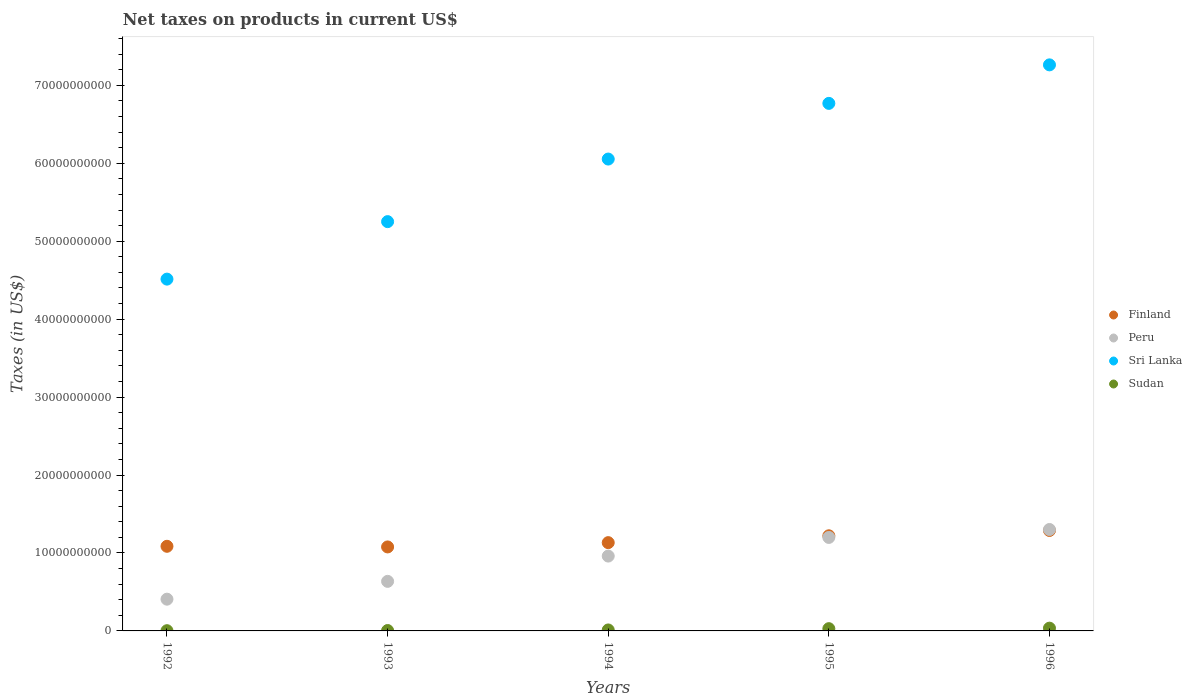What is the net taxes on products in Sudan in 1992?
Ensure brevity in your answer.  2.94e+07. Across all years, what is the maximum net taxes on products in Sudan?
Provide a short and direct response. 3.55e+08. Across all years, what is the minimum net taxes on products in Sudan?
Your response must be concise. 2.94e+07. In which year was the net taxes on products in Finland maximum?
Provide a short and direct response. 1996. In which year was the net taxes on products in Sudan minimum?
Keep it short and to the point. 1992. What is the total net taxes on products in Sri Lanka in the graph?
Keep it short and to the point. 2.98e+11. What is the difference between the net taxes on products in Sudan in 1994 and that in 1996?
Provide a short and direct response. -2.30e+08. What is the difference between the net taxes on products in Peru in 1993 and the net taxes on products in Sri Lanka in 1992?
Provide a short and direct response. -3.88e+1. What is the average net taxes on products in Sudan per year?
Keep it short and to the point. 1.70e+08. In the year 1996, what is the difference between the net taxes on products in Sri Lanka and net taxes on products in Finland?
Offer a very short reply. 5.97e+1. In how many years, is the net taxes on products in Sudan greater than 36000000000 US$?
Offer a very short reply. 0. What is the ratio of the net taxes on products in Sudan in 1992 to that in 1995?
Keep it short and to the point. 0.1. Is the difference between the net taxes on products in Sri Lanka in 1993 and 1994 greater than the difference between the net taxes on products in Finland in 1993 and 1994?
Give a very brief answer. No. What is the difference between the highest and the second highest net taxes on products in Sri Lanka?
Offer a very short reply. 4.94e+09. What is the difference between the highest and the lowest net taxes on products in Sudan?
Your answer should be very brief. 3.26e+08. In how many years, is the net taxes on products in Sri Lanka greater than the average net taxes on products in Sri Lanka taken over all years?
Provide a short and direct response. 3. Is the sum of the net taxes on products in Finland in 1994 and 1996 greater than the maximum net taxes on products in Sudan across all years?
Provide a short and direct response. Yes. Is it the case that in every year, the sum of the net taxes on products in Sri Lanka and net taxes on products in Sudan  is greater than the net taxes on products in Peru?
Ensure brevity in your answer.  Yes. Does the net taxes on products in Finland monotonically increase over the years?
Provide a short and direct response. No. Is the net taxes on products in Sri Lanka strictly greater than the net taxes on products in Finland over the years?
Keep it short and to the point. Yes. Is the net taxes on products in Peru strictly less than the net taxes on products in Finland over the years?
Make the answer very short. No. How many dotlines are there?
Ensure brevity in your answer.  4. How many years are there in the graph?
Give a very brief answer. 5. What is the difference between two consecutive major ticks on the Y-axis?
Your response must be concise. 1.00e+1. Does the graph contain grids?
Provide a short and direct response. No. How many legend labels are there?
Keep it short and to the point. 4. What is the title of the graph?
Your answer should be very brief. Net taxes on products in current US$. Does "Sub-Saharan Africa (all income levels)" appear as one of the legend labels in the graph?
Provide a succinct answer. No. What is the label or title of the Y-axis?
Provide a short and direct response. Taxes (in US$). What is the Taxes (in US$) in Finland in 1992?
Ensure brevity in your answer.  1.09e+1. What is the Taxes (in US$) of Peru in 1992?
Your answer should be very brief. 4.07e+09. What is the Taxes (in US$) in Sri Lanka in 1992?
Provide a succinct answer. 4.51e+1. What is the Taxes (in US$) in Sudan in 1992?
Provide a short and direct response. 2.94e+07. What is the Taxes (in US$) in Finland in 1993?
Offer a very short reply. 1.08e+1. What is the Taxes (in US$) in Peru in 1993?
Your answer should be compact. 6.36e+09. What is the Taxes (in US$) in Sri Lanka in 1993?
Provide a succinct answer. 5.25e+1. What is the Taxes (in US$) in Sudan in 1993?
Your answer should be very brief. 5.04e+07. What is the Taxes (in US$) of Finland in 1994?
Offer a terse response. 1.13e+1. What is the Taxes (in US$) of Peru in 1994?
Your answer should be very brief. 9.60e+09. What is the Taxes (in US$) of Sri Lanka in 1994?
Your answer should be compact. 6.05e+1. What is the Taxes (in US$) of Sudan in 1994?
Your answer should be compact. 1.25e+08. What is the Taxes (in US$) in Finland in 1995?
Ensure brevity in your answer.  1.22e+1. What is the Taxes (in US$) of Peru in 1995?
Offer a very short reply. 1.20e+1. What is the Taxes (in US$) of Sri Lanka in 1995?
Keep it short and to the point. 6.77e+1. What is the Taxes (in US$) of Sudan in 1995?
Your response must be concise. 2.90e+08. What is the Taxes (in US$) of Finland in 1996?
Your answer should be very brief. 1.29e+1. What is the Taxes (in US$) in Peru in 1996?
Provide a succinct answer. 1.30e+1. What is the Taxes (in US$) of Sri Lanka in 1996?
Provide a short and direct response. 7.26e+1. What is the Taxes (in US$) of Sudan in 1996?
Your answer should be compact. 3.55e+08. Across all years, what is the maximum Taxes (in US$) of Finland?
Give a very brief answer. 1.29e+1. Across all years, what is the maximum Taxes (in US$) in Peru?
Ensure brevity in your answer.  1.30e+1. Across all years, what is the maximum Taxes (in US$) in Sri Lanka?
Your answer should be very brief. 7.26e+1. Across all years, what is the maximum Taxes (in US$) of Sudan?
Provide a succinct answer. 3.55e+08. Across all years, what is the minimum Taxes (in US$) in Finland?
Provide a short and direct response. 1.08e+1. Across all years, what is the minimum Taxes (in US$) of Peru?
Provide a short and direct response. 4.07e+09. Across all years, what is the minimum Taxes (in US$) in Sri Lanka?
Give a very brief answer. 4.51e+1. Across all years, what is the minimum Taxes (in US$) in Sudan?
Your answer should be very brief. 2.94e+07. What is the total Taxes (in US$) in Finland in the graph?
Give a very brief answer. 5.81e+1. What is the total Taxes (in US$) of Peru in the graph?
Make the answer very short. 4.50e+1. What is the total Taxes (in US$) of Sri Lanka in the graph?
Ensure brevity in your answer.  2.98e+11. What is the total Taxes (in US$) of Sudan in the graph?
Your response must be concise. 8.49e+08. What is the difference between the Taxes (in US$) in Finland in 1992 and that in 1993?
Offer a terse response. 8.20e+07. What is the difference between the Taxes (in US$) of Peru in 1992 and that in 1993?
Make the answer very short. -2.29e+09. What is the difference between the Taxes (in US$) of Sri Lanka in 1992 and that in 1993?
Ensure brevity in your answer.  -7.38e+09. What is the difference between the Taxes (in US$) of Sudan in 1992 and that in 1993?
Offer a very short reply. -2.11e+07. What is the difference between the Taxes (in US$) in Finland in 1992 and that in 1994?
Your answer should be very brief. -4.69e+08. What is the difference between the Taxes (in US$) in Peru in 1992 and that in 1994?
Give a very brief answer. -5.53e+09. What is the difference between the Taxes (in US$) of Sri Lanka in 1992 and that in 1994?
Your answer should be compact. -1.54e+1. What is the difference between the Taxes (in US$) of Sudan in 1992 and that in 1994?
Provide a short and direct response. -9.51e+07. What is the difference between the Taxes (in US$) in Finland in 1992 and that in 1995?
Your response must be concise. -1.35e+09. What is the difference between the Taxes (in US$) in Peru in 1992 and that in 1995?
Provide a short and direct response. -7.92e+09. What is the difference between the Taxes (in US$) in Sri Lanka in 1992 and that in 1995?
Give a very brief answer. -2.25e+1. What is the difference between the Taxes (in US$) in Sudan in 1992 and that in 1995?
Make the answer very short. -2.60e+08. What is the difference between the Taxes (in US$) in Finland in 1992 and that in 1996?
Offer a terse response. -2.03e+09. What is the difference between the Taxes (in US$) in Peru in 1992 and that in 1996?
Offer a terse response. -8.94e+09. What is the difference between the Taxes (in US$) in Sri Lanka in 1992 and that in 1996?
Give a very brief answer. -2.75e+1. What is the difference between the Taxes (in US$) of Sudan in 1992 and that in 1996?
Offer a very short reply. -3.26e+08. What is the difference between the Taxes (in US$) of Finland in 1993 and that in 1994?
Make the answer very short. -5.51e+08. What is the difference between the Taxes (in US$) in Peru in 1993 and that in 1994?
Your response must be concise. -3.25e+09. What is the difference between the Taxes (in US$) in Sri Lanka in 1993 and that in 1994?
Offer a very short reply. -8.03e+09. What is the difference between the Taxes (in US$) in Sudan in 1993 and that in 1994?
Give a very brief answer. -7.41e+07. What is the difference between the Taxes (in US$) of Finland in 1993 and that in 1995?
Ensure brevity in your answer.  -1.43e+09. What is the difference between the Taxes (in US$) in Peru in 1993 and that in 1995?
Ensure brevity in your answer.  -5.64e+09. What is the difference between the Taxes (in US$) of Sri Lanka in 1993 and that in 1995?
Offer a terse response. -1.52e+1. What is the difference between the Taxes (in US$) in Sudan in 1993 and that in 1995?
Give a very brief answer. -2.39e+08. What is the difference between the Taxes (in US$) in Finland in 1993 and that in 1996?
Provide a short and direct response. -2.11e+09. What is the difference between the Taxes (in US$) in Peru in 1993 and that in 1996?
Offer a terse response. -6.65e+09. What is the difference between the Taxes (in US$) in Sri Lanka in 1993 and that in 1996?
Ensure brevity in your answer.  -2.01e+1. What is the difference between the Taxes (in US$) in Sudan in 1993 and that in 1996?
Your response must be concise. -3.05e+08. What is the difference between the Taxes (in US$) of Finland in 1994 and that in 1995?
Ensure brevity in your answer.  -8.78e+08. What is the difference between the Taxes (in US$) in Peru in 1994 and that in 1995?
Keep it short and to the point. -2.39e+09. What is the difference between the Taxes (in US$) of Sri Lanka in 1994 and that in 1995?
Your response must be concise. -7.14e+09. What is the difference between the Taxes (in US$) in Sudan in 1994 and that in 1995?
Offer a terse response. -1.65e+08. What is the difference between the Taxes (in US$) in Finland in 1994 and that in 1996?
Ensure brevity in your answer.  -1.56e+09. What is the difference between the Taxes (in US$) in Peru in 1994 and that in 1996?
Offer a terse response. -3.41e+09. What is the difference between the Taxes (in US$) of Sri Lanka in 1994 and that in 1996?
Give a very brief answer. -1.21e+1. What is the difference between the Taxes (in US$) of Sudan in 1994 and that in 1996?
Provide a succinct answer. -2.30e+08. What is the difference between the Taxes (in US$) of Finland in 1995 and that in 1996?
Provide a short and direct response. -6.85e+08. What is the difference between the Taxes (in US$) of Peru in 1995 and that in 1996?
Ensure brevity in your answer.  -1.02e+09. What is the difference between the Taxes (in US$) in Sri Lanka in 1995 and that in 1996?
Keep it short and to the point. -4.94e+09. What is the difference between the Taxes (in US$) in Sudan in 1995 and that in 1996?
Your answer should be compact. -6.54e+07. What is the difference between the Taxes (in US$) in Finland in 1992 and the Taxes (in US$) in Peru in 1993?
Ensure brevity in your answer.  4.50e+09. What is the difference between the Taxes (in US$) in Finland in 1992 and the Taxes (in US$) in Sri Lanka in 1993?
Your answer should be compact. -4.17e+1. What is the difference between the Taxes (in US$) in Finland in 1992 and the Taxes (in US$) in Sudan in 1993?
Keep it short and to the point. 1.08e+1. What is the difference between the Taxes (in US$) in Peru in 1992 and the Taxes (in US$) in Sri Lanka in 1993?
Your answer should be compact. -4.84e+1. What is the difference between the Taxes (in US$) of Peru in 1992 and the Taxes (in US$) of Sudan in 1993?
Ensure brevity in your answer.  4.02e+09. What is the difference between the Taxes (in US$) in Sri Lanka in 1992 and the Taxes (in US$) in Sudan in 1993?
Offer a very short reply. 4.51e+1. What is the difference between the Taxes (in US$) of Finland in 1992 and the Taxes (in US$) of Peru in 1994?
Offer a very short reply. 1.25e+09. What is the difference between the Taxes (in US$) in Finland in 1992 and the Taxes (in US$) in Sri Lanka in 1994?
Keep it short and to the point. -4.97e+1. What is the difference between the Taxes (in US$) in Finland in 1992 and the Taxes (in US$) in Sudan in 1994?
Offer a terse response. 1.07e+1. What is the difference between the Taxes (in US$) in Peru in 1992 and the Taxes (in US$) in Sri Lanka in 1994?
Ensure brevity in your answer.  -5.65e+1. What is the difference between the Taxes (in US$) of Peru in 1992 and the Taxes (in US$) of Sudan in 1994?
Give a very brief answer. 3.95e+09. What is the difference between the Taxes (in US$) in Sri Lanka in 1992 and the Taxes (in US$) in Sudan in 1994?
Give a very brief answer. 4.50e+1. What is the difference between the Taxes (in US$) in Finland in 1992 and the Taxes (in US$) in Peru in 1995?
Ensure brevity in your answer.  -1.14e+09. What is the difference between the Taxes (in US$) of Finland in 1992 and the Taxes (in US$) of Sri Lanka in 1995?
Your answer should be very brief. -5.68e+1. What is the difference between the Taxes (in US$) in Finland in 1992 and the Taxes (in US$) in Sudan in 1995?
Your answer should be compact. 1.06e+1. What is the difference between the Taxes (in US$) of Peru in 1992 and the Taxes (in US$) of Sri Lanka in 1995?
Offer a very short reply. -6.36e+1. What is the difference between the Taxes (in US$) in Peru in 1992 and the Taxes (in US$) in Sudan in 1995?
Ensure brevity in your answer.  3.78e+09. What is the difference between the Taxes (in US$) in Sri Lanka in 1992 and the Taxes (in US$) in Sudan in 1995?
Offer a very short reply. 4.48e+1. What is the difference between the Taxes (in US$) of Finland in 1992 and the Taxes (in US$) of Peru in 1996?
Your response must be concise. -2.16e+09. What is the difference between the Taxes (in US$) of Finland in 1992 and the Taxes (in US$) of Sri Lanka in 1996?
Ensure brevity in your answer.  -6.18e+1. What is the difference between the Taxes (in US$) in Finland in 1992 and the Taxes (in US$) in Sudan in 1996?
Ensure brevity in your answer.  1.05e+1. What is the difference between the Taxes (in US$) of Peru in 1992 and the Taxes (in US$) of Sri Lanka in 1996?
Offer a terse response. -6.85e+1. What is the difference between the Taxes (in US$) in Peru in 1992 and the Taxes (in US$) in Sudan in 1996?
Keep it short and to the point. 3.72e+09. What is the difference between the Taxes (in US$) of Sri Lanka in 1992 and the Taxes (in US$) of Sudan in 1996?
Keep it short and to the point. 4.48e+1. What is the difference between the Taxes (in US$) in Finland in 1993 and the Taxes (in US$) in Peru in 1994?
Provide a short and direct response. 1.17e+09. What is the difference between the Taxes (in US$) in Finland in 1993 and the Taxes (in US$) in Sri Lanka in 1994?
Give a very brief answer. -4.98e+1. What is the difference between the Taxes (in US$) in Finland in 1993 and the Taxes (in US$) in Sudan in 1994?
Keep it short and to the point. 1.07e+1. What is the difference between the Taxes (in US$) in Peru in 1993 and the Taxes (in US$) in Sri Lanka in 1994?
Ensure brevity in your answer.  -5.42e+1. What is the difference between the Taxes (in US$) in Peru in 1993 and the Taxes (in US$) in Sudan in 1994?
Keep it short and to the point. 6.23e+09. What is the difference between the Taxes (in US$) of Sri Lanka in 1993 and the Taxes (in US$) of Sudan in 1994?
Keep it short and to the point. 5.24e+1. What is the difference between the Taxes (in US$) in Finland in 1993 and the Taxes (in US$) in Peru in 1995?
Offer a very short reply. -1.22e+09. What is the difference between the Taxes (in US$) of Finland in 1993 and the Taxes (in US$) of Sri Lanka in 1995?
Ensure brevity in your answer.  -5.69e+1. What is the difference between the Taxes (in US$) of Finland in 1993 and the Taxes (in US$) of Sudan in 1995?
Give a very brief answer. 1.05e+1. What is the difference between the Taxes (in US$) in Peru in 1993 and the Taxes (in US$) in Sri Lanka in 1995?
Your answer should be very brief. -6.13e+1. What is the difference between the Taxes (in US$) of Peru in 1993 and the Taxes (in US$) of Sudan in 1995?
Give a very brief answer. 6.07e+09. What is the difference between the Taxes (in US$) of Sri Lanka in 1993 and the Taxes (in US$) of Sudan in 1995?
Keep it short and to the point. 5.22e+1. What is the difference between the Taxes (in US$) in Finland in 1993 and the Taxes (in US$) in Peru in 1996?
Make the answer very short. -2.24e+09. What is the difference between the Taxes (in US$) of Finland in 1993 and the Taxes (in US$) of Sri Lanka in 1996?
Ensure brevity in your answer.  -6.18e+1. What is the difference between the Taxes (in US$) of Finland in 1993 and the Taxes (in US$) of Sudan in 1996?
Ensure brevity in your answer.  1.04e+1. What is the difference between the Taxes (in US$) of Peru in 1993 and the Taxes (in US$) of Sri Lanka in 1996?
Offer a very short reply. -6.63e+1. What is the difference between the Taxes (in US$) in Peru in 1993 and the Taxes (in US$) in Sudan in 1996?
Your answer should be compact. 6.00e+09. What is the difference between the Taxes (in US$) in Sri Lanka in 1993 and the Taxes (in US$) in Sudan in 1996?
Your answer should be compact. 5.22e+1. What is the difference between the Taxes (in US$) in Finland in 1994 and the Taxes (in US$) in Peru in 1995?
Your answer should be compact. -6.68e+08. What is the difference between the Taxes (in US$) of Finland in 1994 and the Taxes (in US$) of Sri Lanka in 1995?
Provide a succinct answer. -5.64e+1. What is the difference between the Taxes (in US$) in Finland in 1994 and the Taxes (in US$) in Sudan in 1995?
Offer a very short reply. 1.10e+1. What is the difference between the Taxes (in US$) of Peru in 1994 and the Taxes (in US$) of Sri Lanka in 1995?
Provide a succinct answer. -5.81e+1. What is the difference between the Taxes (in US$) in Peru in 1994 and the Taxes (in US$) in Sudan in 1995?
Your response must be concise. 9.31e+09. What is the difference between the Taxes (in US$) of Sri Lanka in 1994 and the Taxes (in US$) of Sudan in 1995?
Give a very brief answer. 6.02e+1. What is the difference between the Taxes (in US$) in Finland in 1994 and the Taxes (in US$) in Peru in 1996?
Your response must be concise. -1.69e+09. What is the difference between the Taxes (in US$) of Finland in 1994 and the Taxes (in US$) of Sri Lanka in 1996?
Give a very brief answer. -6.13e+1. What is the difference between the Taxes (in US$) in Finland in 1994 and the Taxes (in US$) in Sudan in 1996?
Your response must be concise. 1.10e+1. What is the difference between the Taxes (in US$) in Peru in 1994 and the Taxes (in US$) in Sri Lanka in 1996?
Keep it short and to the point. -6.30e+1. What is the difference between the Taxes (in US$) in Peru in 1994 and the Taxes (in US$) in Sudan in 1996?
Provide a succinct answer. 9.25e+09. What is the difference between the Taxes (in US$) in Sri Lanka in 1994 and the Taxes (in US$) in Sudan in 1996?
Give a very brief answer. 6.02e+1. What is the difference between the Taxes (in US$) in Finland in 1995 and the Taxes (in US$) in Peru in 1996?
Make the answer very short. -8.09e+08. What is the difference between the Taxes (in US$) in Finland in 1995 and the Taxes (in US$) in Sri Lanka in 1996?
Offer a very short reply. -6.04e+1. What is the difference between the Taxes (in US$) in Finland in 1995 and the Taxes (in US$) in Sudan in 1996?
Make the answer very short. 1.18e+1. What is the difference between the Taxes (in US$) in Peru in 1995 and the Taxes (in US$) in Sri Lanka in 1996?
Offer a very short reply. -6.06e+1. What is the difference between the Taxes (in US$) of Peru in 1995 and the Taxes (in US$) of Sudan in 1996?
Make the answer very short. 1.16e+1. What is the difference between the Taxes (in US$) of Sri Lanka in 1995 and the Taxes (in US$) of Sudan in 1996?
Make the answer very short. 6.73e+1. What is the average Taxes (in US$) in Finland per year?
Your answer should be compact. 1.16e+1. What is the average Taxes (in US$) of Peru per year?
Offer a terse response. 9.01e+09. What is the average Taxes (in US$) in Sri Lanka per year?
Offer a very short reply. 5.97e+1. What is the average Taxes (in US$) of Sudan per year?
Keep it short and to the point. 1.70e+08. In the year 1992, what is the difference between the Taxes (in US$) of Finland and Taxes (in US$) of Peru?
Make the answer very short. 6.78e+09. In the year 1992, what is the difference between the Taxes (in US$) in Finland and Taxes (in US$) in Sri Lanka?
Give a very brief answer. -3.43e+1. In the year 1992, what is the difference between the Taxes (in US$) of Finland and Taxes (in US$) of Sudan?
Keep it short and to the point. 1.08e+1. In the year 1992, what is the difference between the Taxes (in US$) in Peru and Taxes (in US$) in Sri Lanka?
Provide a succinct answer. -4.11e+1. In the year 1992, what is the difference between the Taxes (in US$) of Peru and Taxes (in US$) of Sudan?
Give a very brief answer. 4.04e+09. In the year 1992, what is the difference between the Taxes (in US$) of Sri Lanka and Taxes (in US$) of Sudan?
Offer a very short reply. 4.51e+1. In the year 1993, what is the difference between the Taxes (in US$) in Finland and Taxes (in US$) in Peru?
Provide a succinct answer. 4.42e+09. In the year 1993, what is the difference between the Taxes (in US$) of Finland and Taxes (in US$) of Sri Lanka?
Provide a succinct answer. -4.17e+1. In the year 1993, what is the difference between the Taxes (in US$) in Finland and Taxes (in US$) in Sudan?
Give a very brief answer. 1.07e+1. In the year 1993, what is the difference between the Taxes (in US$) in Peru and Taxes (in US$) in Sri Lanka?
Provide a short and direct response. -4.62e+1. In the year 1993, what is the difference between the Taxes (in US$) in Peru and Taxes (in US$) in Sudan?
Provide a succinct answer. 6.31e+09. In the year 1993, what is the difference between the Taxes (in US$) of Sri Lanka and Taxes (in US$) of Sudan?
Ensure brevity in your answer.  5.25e+1. In the year 1994, what is the difference between the Taxes (in US$) in Finland and Taxes (in US$) in Peru?
Give a very brief answer. 1.72e+09. In the year 1994, what is the difference between the Taxes (in US$) of Finland and Taxes (in US$) of Sri Lanka?
Ensure brevity in your answer.  -4.92e+1. In the year 1994, what is the difference between the Taxes (in US$) of Finland and Taxes (in US$) of Sudan?
Provide a short and direct response. 1.12e+1. In the year 1994, what is the difference between the Taxes (in US$) in Peru and Taxes (in US$) in Sri Lanka?
Ensure brevity in your answer.  -5.09e+1. In the year 1994, what is the difference between the Taxes (in US$) in Peru and Taxes (in US$) in Sudan?
Keep it short and to the point. 9.48e+09. In the year 1994, what is the difference between the Taxes (in US$) of Sri Lanka and Taxes (in US$) of Sudan?
Make the answer very short. 6.04e+1. In the year 1995, what is the difference between the Taxes (in US$) in Finland and Taxes (in US$) in Peru?
Give a very brief answer. 2.10e+08. In the year 1995, what is the difference between the Taxes (in US$) in Finland and Taxes (in US$) in Sri Lanka?
Provide a short and direct response. -5.55e+1. In the year 1995, what is the difference between the Taxes (in US$) of Finland and Taxes (in US$) of Sudan?
Provide a short and direct response. 1.19e+1. In the year 1995, what is the difference between the Taxes (in US$) in Peru and Taxes (in US$) in Sri Lanka?
Ensure brevity in your answer.  -5.57e+1. In the year 1995, what is the difference between the Taxes (in US$) in Peru and Taxes (in US$) in Sudan?
Give a very brief answer. 1.17e+1. In the year 1995, what is the difference between the Taxes (in US$) in Sri Lanka and Taxes (in US$) in Sudan?
Offer a terse response. 6.74e+1. In the year 1996, what is the difference between the Taxes (in US$) of Finland and Taxes (in US$) of Peru?
Make the answer very short. -1.24e+08. In the year 1996, what is the difference between the Taxes (in US$) of Finland and Taxes (in US$) of Sri Lanka?
Provide a succinct answer. -5.97e+1. In the year 1996, what is the difference between the Taxes (in US$) of Finland and Taxes (in US$) of Sudan?
Your answer should be compact. 1.25e+1. In the year 1996, what is the difference between the Taxes (in US$) of Peru and Taxes (in US$) of Sri Lanka?
Your answer should be very brief. -5.96e+1. In the year 1996, what is the difference between the Taxes (in US$) in Peru and Taxes (in US$) in Sudan?
Provide a succinct answer. 1.27e+1. In the year 1996, what is the difference between the Taxes (in US$) in Sri Lanka and Taxes (in US$) in Sudan?
Ensure brevity in your answer.  7.23e+1. What is the ratio of the Taxes (in US$) in Finland in 1992 to that in 1993?
Your response must be concise. 1.01. What is the ratio of the Taxes (in US$) in Peru in 1992 to that in 1993?
Keep it short and to the point. 0.64. What is the ratio of the Taxes (in US$) of Sri Lanka in 1992 to that in 1993?
Provide a succinct answer. 0.86. What is the ratio of the Taxes (in US$) in Sudan in 1992 to that in 1993?
Offer a terse response. 0.58. What is the ratio of the Taxes (in US$) of Finland in 1992 to that in 1994?
Provide a succinct answer. 0.96. What is the ratio of the Taxes (in US$) of Peru in 1992 to that in 1994?
Ensure brevity in your answer.  0.42. What is the ratio of the Taxes (in US$) in Sri Lanka in 1992 to that in 1994?
Give a very brief answer. 0.75. What is the ratio of the Taxes (in US$) of Sudan in 1992 to that in 1994?
Offer a very short reply. 0.24. What is the ratio of the Taxes (in US$) in Finland in 1992 to that in 1995?
Offer a very short reply. 0.89. What is the ratio of the Taxes (in US$) in Peru in 1992 to that in 1995?
Make the answer very short. 0.34. What is the ratio of the Taxes (in US$) of Sri Lanka in 1992 to that in 1995?
Offer a terse response. 0.67. What is the ratio of the Taxes (in US$) of Sudan in 1992 to that in 1995?
Provide a short and direct response. 0.1. What is the ratio of the Taxes (in US$) in Finland in 1992 to that in 1996?
Ensure brevity in your answer.  0.84. What is the ratio of the Taxes (in US$) of Peru in 1992 to that in 1996?
Your answer should be very brief. 0.31. What is the ratio of the Taxes (in US$) in Sri Lanka in 1992 to that in 1996?
Make the answer very short. 0.62. What is the ratio of the Taxes (in US$) in Sudan in 1992 to that in 1996?
Give a very brief answer. 0.08. What is the ratio of the Taxes (in US$) in Finland in 1993 to that in 1994?
Make the answer very short. 0.95. What is the ratio of the Taxes (in US$) in Peru in 1993 to that in 1994?
Keep it short and to the point. 0.66. What is the ratio of the Taxes (in US$) of Sri Lanka in 1993 to that in 1994?
Your answer should be compact. 0.87. What is the ratio of the Taxes (in US$) of Sudan in 1993 to that in 1994?
Keep it short and to the point. 0.41. What is the ratio of the Taxes (in US$) of Finland in 1993 to that in 1995?
Make the answer very short. 0.88. What is the ratio of the Taxes (in US$) of Peru in 1993 to that in 1995?
Offer a terse response. 0.53. What is the ratio of the Taxes (in US$) in Sri Lanka in 1993 to that in 1995?
Provide a succinct answer. 0.78. What is the ratio of the Taxes (in US$) in Sudan in 1993 to that in 1995?
Provide a succinct answer. 0.17. What is the ratio of the Taxes (in US$) in Finland in 1993 to that in 1996?
Keep it short and to the point. 0.84. What is the ratio of the Taxes (in US$) in Peru in 1993 to that in 1996?
Your answer should be very brief. 0.49. What is the ratio of the Taxes (in US$) in Sri Lanka in 1993 to that in 1996?
Your answer should be compact. 0.72. What is the ratio of the Taxes (in US$) of Sudan in 1993 to that in 1996?
Make the answer very short. 0.14. What is the ratio of the Taxes (in US$) of Finland in 1994 to that in 1995?
Provide a succinct answer. 0.93. What is the ratio of the Taxes (in US$) in Peru in 1994 to that in 1995?
Keep it short and to the point. 0.8. What is the ratio of the Taxes (in US$) of Sri Lanka in 1994 to that in 1995?
Make the answer very short. 0.89. What is the ratio of the Taxes (in US$) of Sudan in 1994 to that in 1995?
Make the answer very short. 0.43. What is the ratio of the Taxes (in US$) of Finland in 1994 to that in 1996?
Keep it short and to the point. 0.88. What is the ratio of the Taxes (in US$) in Peru in 1994 to that in 1996?
Provide a short and direct response. 0.74. What is the ratio of the Taxes (in US$) of Sri Lanka in 1994 to that in 1996?
Keep it short and to the point. 0.83. What is the ratio of the Taxes (in US$) in Sudan in 1994 to that in 1996?
Ensure brevity in your answer.  0.35. What is the ratio of the Taxes (in US$) of Finland in 1995 to that in 1996?
Your answer should be compact. 0.95. What is the ratio of the Taxes (in US$) in Peru in 1995 to that in 1996?
Your response must be concise. 0.92. What is the ratio of the Taxes (in US$) of Sri Lanka in 1995 to that in 1996?
Give a very brief answer. 0.93. What is the ratio of the Taxes (in US$) of Sudan in 1995 to that in 1996?
Give a very brief answer. 0.82. What is the difference between the highest and the second highest Taxes (in US$) in Finland?
Your answer should be very brief. 6.85e+08. What is the difference between the highest and the second highest Taxes (in US$) in Peru?
Give a very brief answer. 1.02e+09. What is the difference between the highest and the second highest Taxes (in US$) in Sri Lanka?
Ensure brevity in your answer.  4.94e+09. What is the difference between the highest and the second highest Taxes (in US$) of Sudan?
Your response must be concise. 6.54e+07. What is the difference between the highest and the lowest Taxes (in US$) of Finland?
Offer a terse response. 2.11e+09. What is the difference between the highest and the lowest Taxes (in US$) of Peru?
Give a very brief answer. 8.94e+09. What is the difference between the highest and the lowest Taxes (in US$) in Sri Lanka?
Provide a succinct answer. 2.75e+1. What is the difference between the highest and the lowest Taxes (in US$) of Sudan?
Keep it short and to the point. 3.26e+08. 